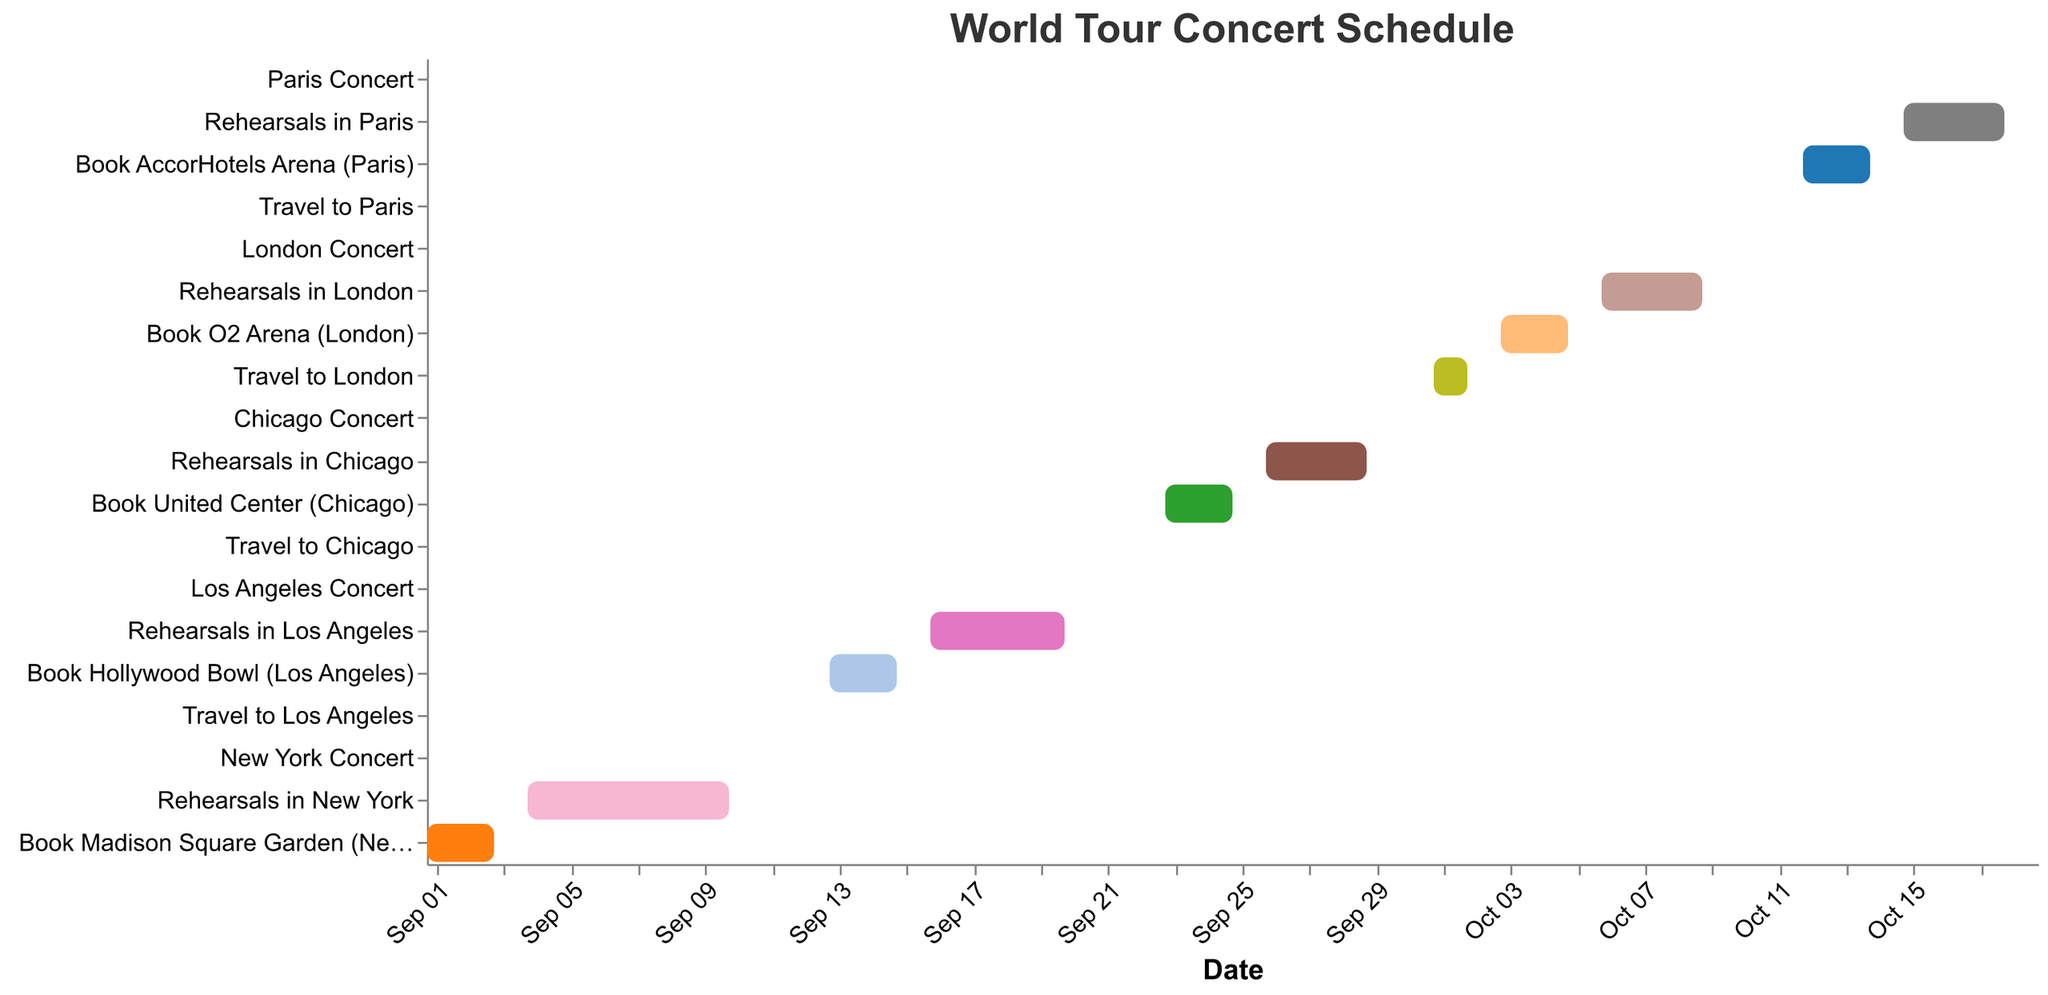How many travel days are scheduled in the entire tour? The Gantt chart shows four travel tasks: Travel to Los Angeles, Travel to Chicago, Travel to London, and Travel to Paris. Each travel task occupies one day. Therefore, there are four travel days scheduled.
Answer: 4 Which city has the longest booking period for the venue? By examining the duration of the booking tasks, we see that New York, Los Angeles, Chicago, London, and Paris have booking periods from September 1-3, 13-15, 23-25, October 3-5, and October 12-14 respectively. Each has a 3-day booking period. Therefore, all cities have an equal booking duration of three days.
Answer: All cities (3 days) How many days are allocated for rehearsals in Los Angeles? Rehearsals in Los Angeles are scheduled from September 16 to September 20. This duration spans 5 days.
Answer: 5 days What's the total duration of the concert tour from the first booking to the last concert? The first task, "Book Madison Square Garden (New York)," starts on September 1, 2023, and the last task, "Paris Concert," ends on October 19, 2023. This amounts to a total of 49 days.
Answer: 49 days Compare the rehearsal durations between New York and London. Which one is longer and by how many days? Rehearsals in New York span from September 4 to September 10, which is 7 days. Rehearsals in London span from October 6 to October 9, which is 4 days. Therefore, New York has longer rehearsals by 3 days.
Answer: New York, 3 days longer What is the average duration of the booking periods across all cities? The booking periods for all cities are: New York (3 days), Los Angeles (3 days), Chicago (3 days), London (3 days), and Paris (3 days). The total duration is 3 + 3 + 3 + 3 + 3 = 15 days, and there are 5 booking tasks. Therefore, the average duration is 15/5.
Answer: 3 days What is the longest continuous stretch (without breaks) of activity in any city? The longest continuous periods of activity can be observed by scoping out overlaps of tasks. For Los Angeles, from September 13 to September 21, we have back-to-back tasks of booking, rehearsals, and the concert. This stretch is 9 days.
Answer: Los Angeles, 9 days 